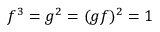Convert formula to latex. <formula><loc_0><loc_0><loc_500><loc_500>f ^ { 3 } = g ^ { 2 } = ( g f ) ^ { 2 } = 1</formula> 